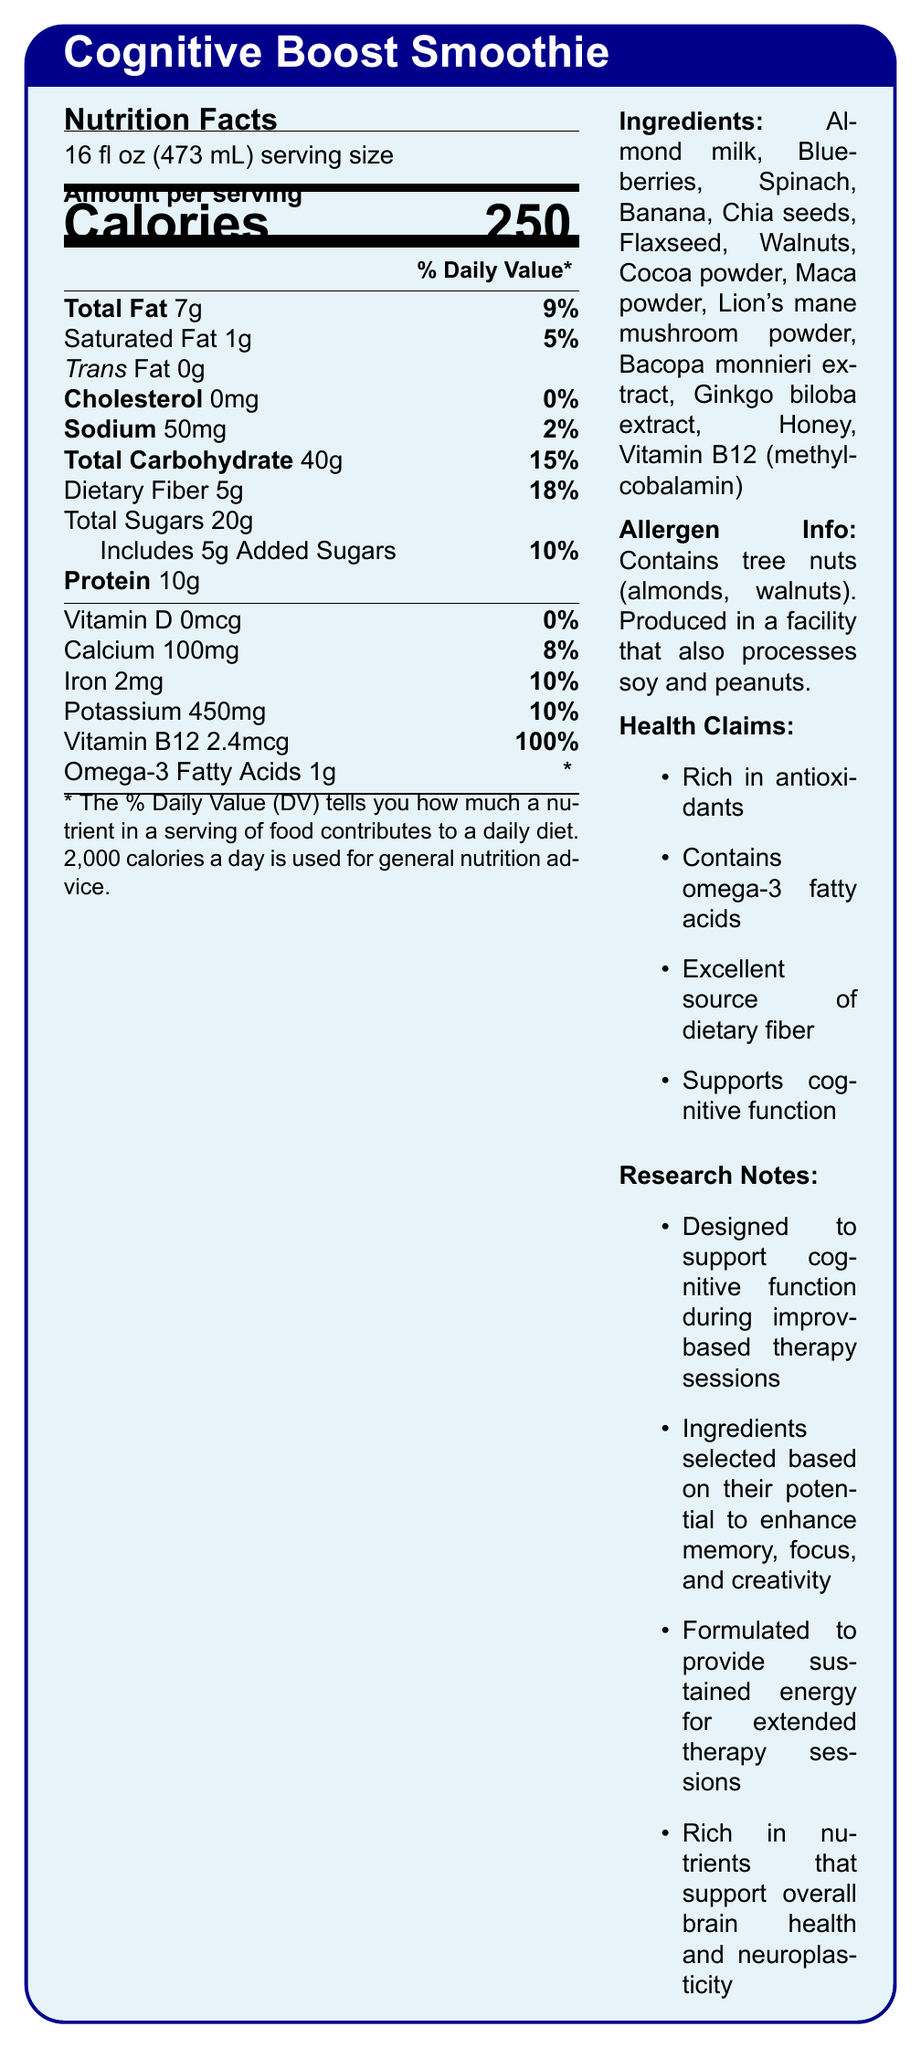What is the serving size of the Cognitive Boost Smoothie? The serving size is clearly stated as "16 fl oz (473 mL)" under the Nutrition Facts section.
Answer: 16 fl oz (473 mL) How many grams of protein are in one serving? The amount of protein per serving is listed as "10g" under the Nutrition Facts.
Answer: 10g What percentage of the daily value for dietary fiber does one serving provide? The daily value percentage for dietary fiber is listed as "18%" under the Nutrition Facts.
Answer: 18% What is the main purpose of the Cognitive Boost Smoothie according to the research notes? The research notes mention that the smoothie is "designed to support cognitive function during improv-based therapy sessions."
Answer: To support cognitive function during improv-based therapy sessions Name three ingredients found in the Cognitive Boost Smoothie. Examples of ingredients include Almond milk, Blueberries, and Spinach, which are listed under the Ingredients section.
Answer: Almond milk, Blueberries, Spinach What is the total amount of sodium in one serving? The total amount of sodium per serving is listed as "50mg" under the Nutrition Facts.
Answer: 50mg Which vitamin is present at 100% of the daily value in the Cognitive Boost Smoothie? A. Vitamin D B. Calcium C. Iron D. Vitamin B12 The Nutrition Facts indicate that Vitamin B12 is provided at 100% of the daily value, while the other vitamins and minerals are provided at different percentages.
Answer: D. Vitamin B12 Which of these statements is true regarding the smoothie? A. It has trans fat B. It is cholesterol-free C. It contains vitamin D D. It is rich in omega-6 fatty acids The Nutrition Facts section shows that the smoothie has "0mg" of cholesterol (0% daily value).
Answer: B. It is cholesterol-free Does the Cognitive Boost Smoothie contain any allergens? The Allergen Info section states that the smoothie contains tree nuts (almonds, walnuts) and is produced in a facility that also processes soy and peanuts.
Answer: Yes Summarize the main idea of the Cognitive Boost Smoothie document. The document covers the nutritional facts, ingredients, allergen information, health claims, and research notes regarding the Cognitive Boost Smoothie, highlighting its benefits for cognitive enhancement and therapy support.
Answer: The Cognitive Boost Smoothie is a nutrient-rich beverage designed to support cognitive function, particularly in improv-based therapy sessions. It includes ingredients known for their potential to enhance memory, focus, and creativity, and it provides sustained energy for extended therapy sessions. The smoothie features various health claims, contains essential vitamins and minerals, and is fortified with omega-3 fatty acids and Bacopa monnieri extract for brain health. What is the amount of Omega-3 fatty acids in one serving? The Nutrition Facts list "Omega-3 Fatty Acids 1g" with no daily value percentage provided.
Answer: 1g Which ingredient is specifically mentioned as a source of Vitamin B12? The Ingredients section lists "Vitamin B12 (methylcobalamin)" as a component.
Answer: Methylcobalamin Is the Cognitive Boost Smoothie an excellent source of dietary fiber? One of the health claims states that the smoothie is an "Excellent source of dietary fiber."
Answer: Yes What are the total carbohydrates in the smoothie, and what percentage of the daily value does it represent? The total carbohydrates are listed as "40g," which represents 15% of the daily value.
Answer: 40g, 15% How many added sugars are in the smoothie? The Nutrition Facts show that the smoothie contains "5g" of added sugars.
Answer: 5g Can we determine how long it takes for the Cognitive Boost Smoothie to show its cognitive benefits? The document does not provide information on how long it takes for the smoothie to show cognitive benefits.
Answer: Cannot be determined 